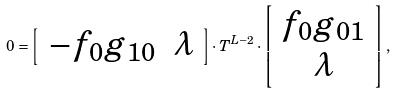<formula> <loc_0><loc_0><loc_500><loc_500>0 = \left [ \begin{array} [ c ] { c c } - f _ { 0 } g _ { 1 0 } & \lambda \end{array} \right ] \cdot T ^ { L - 2 } \cdot \left [ \begin{array} [ c ] { c } f _ { 0 } g _ { 0 1 } \\ \lambda \end{array} \right ] ,</formula> 